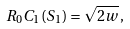<formula> <loc_0><loc_0><loc_500><loc_500>R _ { 0 } C _ { 1 } ( S _ { 1 } ) = \sqrt { 2 w } \, ,</formula> 